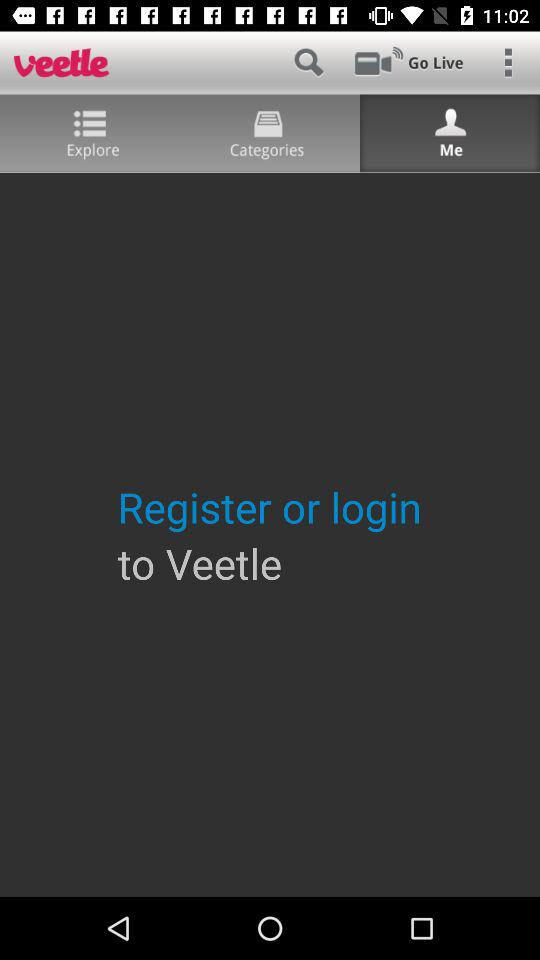Which tab is selected? The selected tab is "Me". 